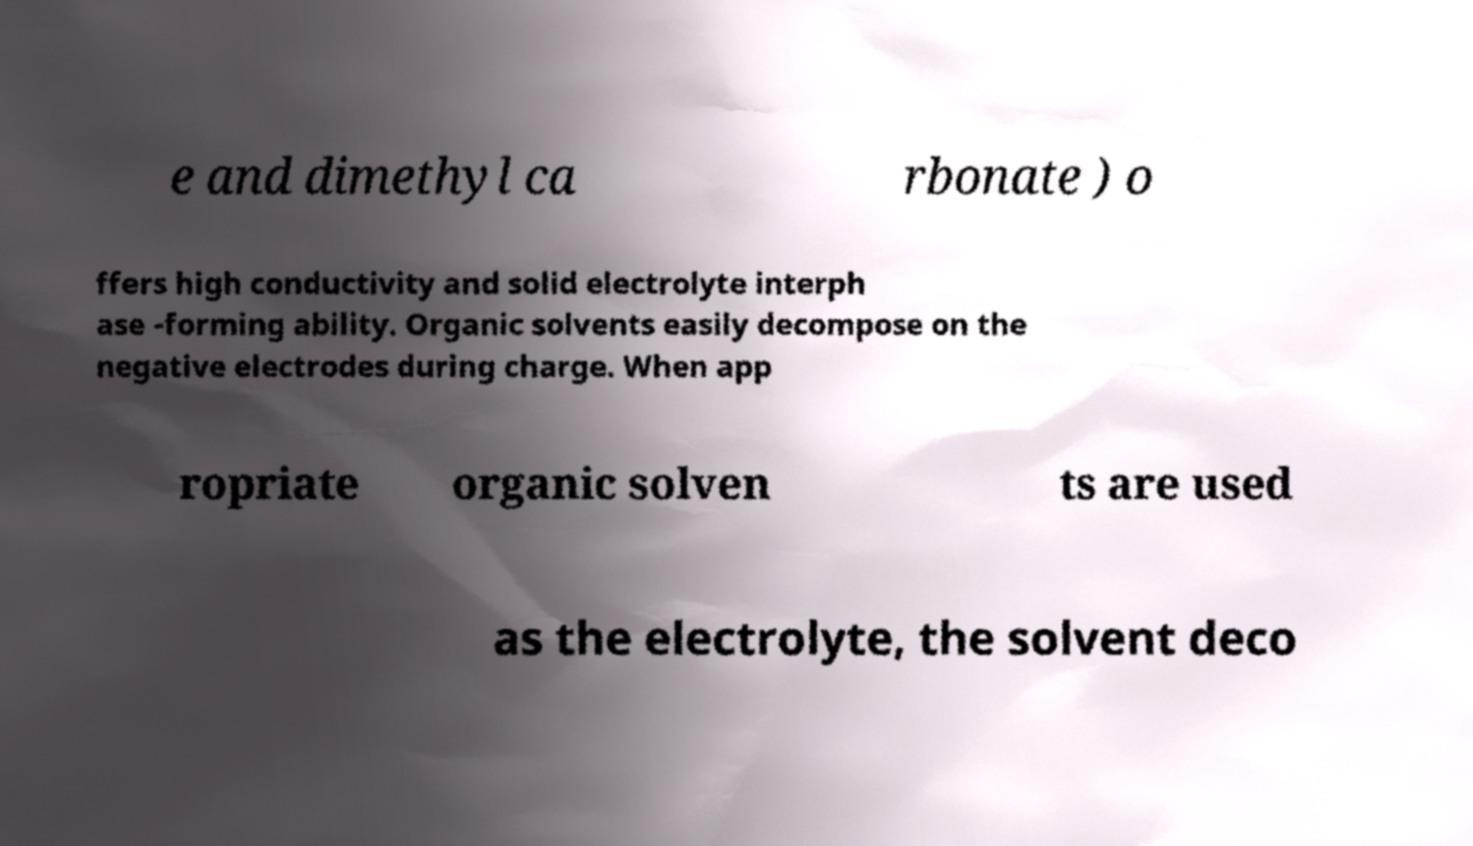For documentation purposes, I need the text within this image transcribed. Could you provide that? e and dimethyl ca rbonate ) o ffers high conductivity and solid electrolyte interph ase -forming ability. Organic solvents easily decompose on the negative electrodes during charge. When app ropriate organic solven ts are used as the electrolyte, the solvent deco 